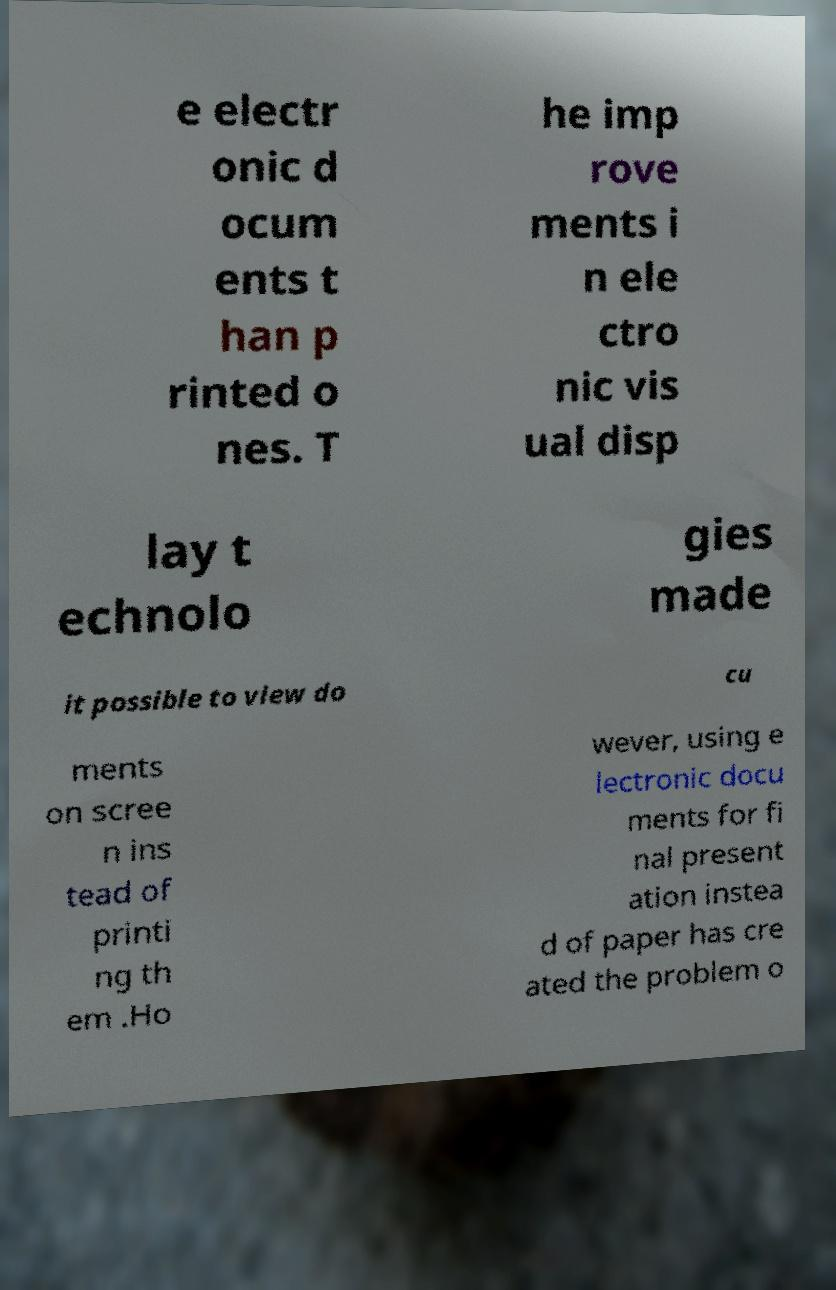I need the written content from this picture converted into text. Can you do that? e electr onic d ocum ents t han p rinted o nes. T he imp rove ments i n ele ctro nic vis ual disp lay t echnolo gies made it possible to view do cu ments on scree n ins tead of printi ng th em .Ho wever, using e lectronic docu ments for fi nal present ation instea d of paper has cre ated the problem o 